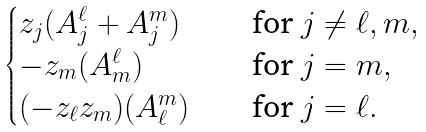Convert formula to latex. <formula><loc_0><loc_0><loc_500><loc_500>\begin{cases} z _ { j } ( A ^ { \ell } _ { j } + A ^ { m } _ { j } ) \quad & \text {for $j\neq \ell, m$} , \\ - z _ { m } ( A ^ { \ell } _ { m } ) \quad & \text {for $j=m$} , \\ ( - z _ { \ell } z _ { m } ) ( A ^ { m } _ { \ell } ) \quad & \text {for $j=\ell$} . \\ \end{cases}</formula> 